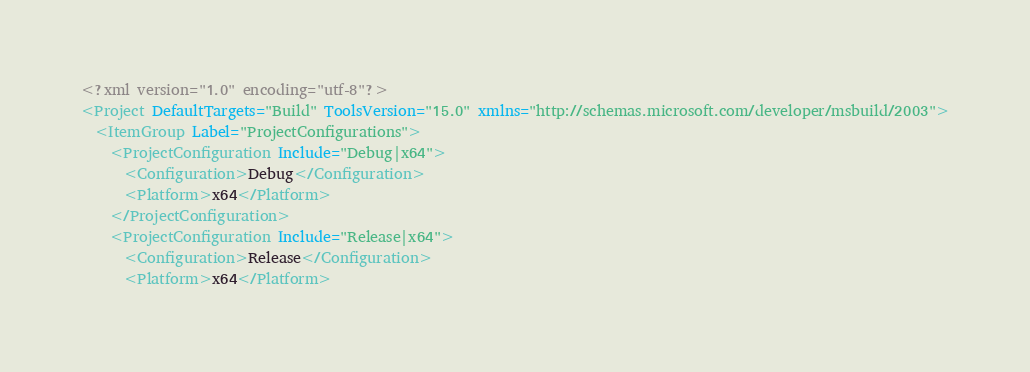Convert code to text. <code><loc_0><loc_0><loc_500><loc_500><_XML_><?xml version="1.0" encoding="utf-8"?>
<Project DefaultTargets="Build" ToolsVersion="15.0" xmlns="http://schemas.microsoft.com/developer/msbuild/2003">
  <ItemGroup Label="ProjectConfigurations">
    <ProjectConfiguration Include="Debug|x64">
      <Configuration>Debug</Configuration>
      <Platform>x64</Platform>
    </ProjectConfiguration>
    <ProjectConfiguration Include="Release|x64">
      <Configuration>Release</Configuration>
      <Platform>x64</Platform></code> 